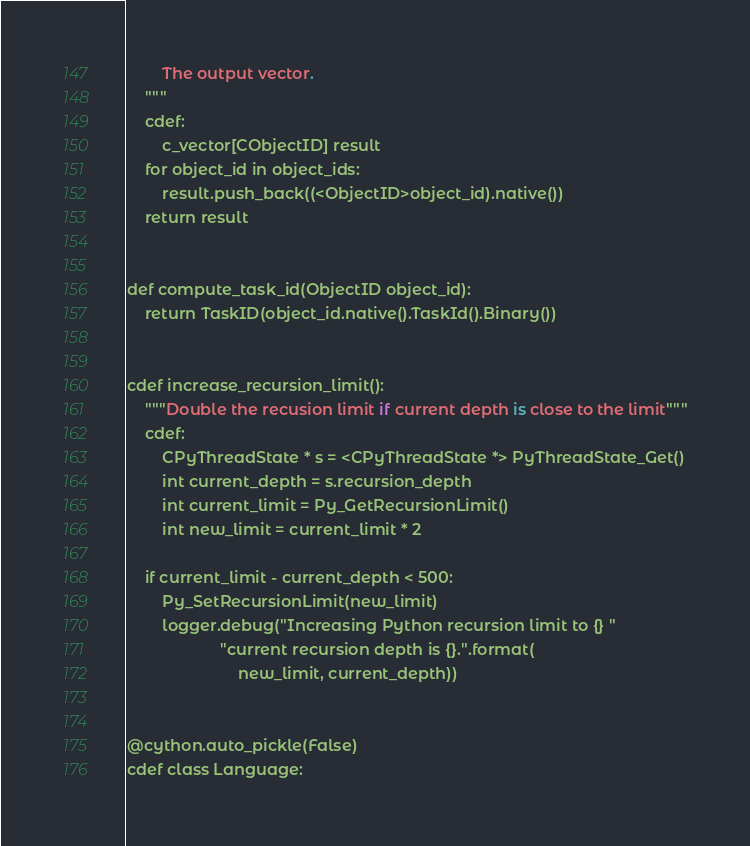Convert code to text. <code><loc_0><loc_0><loc_500><loc_500><_Cython_>        The output vector.
    """
    cdef:
        c_vector[CObjectID] result
    for object_id in object_ids:
        result.push_back((<ObjectID>object_id).native())
    return result


def compute_task_id(ObjectID object_id):
    return TaskID(object_id.native().TaskId().Binary())


cdef increase_recursion_limit():
    """Double the recusion limit if current depth is close to the limit"""
    cdef:
        CPyThreadState * s = <CPyThreadState *> PyThreadState_Get()
        int current_depth = s.recursion_depth
        int current_limit = Py_GetRecursionLimit()
        int new_limit = current_limit * 2

    if current_limit - current_depth < 500:
        Py_SetRecursionLimit(new_limit)
        logger.debug("Increasing Python recursion limit to {} "
                     "current recursion depth is {}.".format(
                         new_limit, current_depth))


@cython.auto_pickle(False)
cdef class Language:</code> 